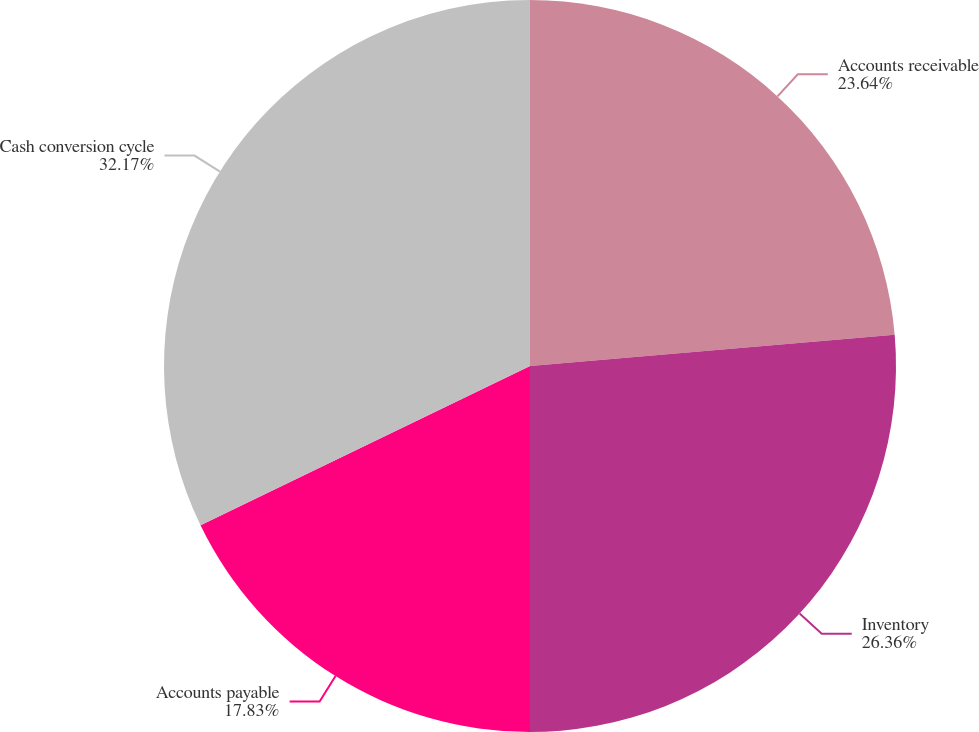Convert chart to OTSL. <chart><loc_0><loc_0><loc_500><loc_500><pie_chart><fcel>Accounts receivable<fcel>Inventory<fcel>Accounts payable<fcel>Cash conversion cycle<nl><fcel>23.64%<fcel>26.36%<fcel>17.83%<fcel>32.17%<nl></chart> 